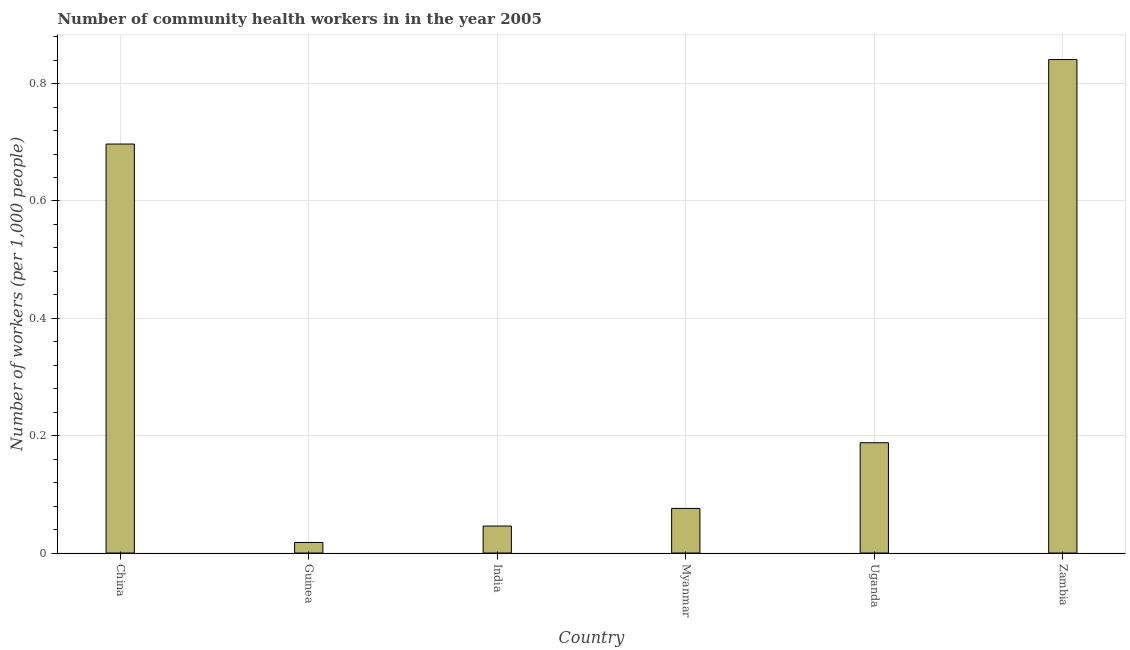Does the graph contain grids?
Your answer should be very brief. Yes. What is the title of the graph?
Give a very brief answer. Number of community health workers in in the year 2005. What is the label or title of the X-axis?
Offer a terse response. Country. What is the label or title of the Y-axis?
Your response must be concise. Number of workers (per 1,0 people). What is the number of community health workers in China?
Your answer should be compact. 0.7. Across all countries, what is the maximum number of community health workers?
Your answer should be compact. 0.84. Across all countries, what is the minimum number of community health workers?
Make the answer very short. 0.02. In which country was the number of community health workers maximum?
Offer a terse response. Zambia. In which country was the number of community health workers minimum?
Offer a terse response. Guinea. What is the sum of the number of community health workers?
Offer a very short reply. 1.87. What is the difference between the number of community health workers in China and Zambia?
Ensure brevity in your answer.  -0.14. What is the average number of community health workers per country?
Offer a terse response. 0.31. What is the median number of community health workers?
Your answer should be very brief. 0.13. In how many countries, is the number of community health workers greater than 0.44 ?
Give a very brief answer. 2. What is the ratio of the number of community health workers in Guinea to that in Myanmar?
Offer a very short reply. 0.24. Is the difference between the number of community health workers in Guinea and India greater than the difference between any two countries?
Provide a short and direct response. No. What is the difference between the highest and the second highest number of community health workers?
Make the answer very short. 0.14. Is the sum of the number of community health workers in India and Zambia greater than the maximum number of community health workers across all countries?
Give a very brief answer. Yes. What is the difference between the highest and the lowest number of community health workers?
Your answer should be compact. 0.82. What is the difference between two consecutive major ticks on the Y-axis?
Provide a succinct answer. 0.2. Are the values on the major ticks of Y-axis written in scientific E-notation?
Offer a very short reply. No. What is the Number of workers (per 1,000 people) in China?
Make the answer very short. 0.7. What is the Number of workers (per 1,000 people) of Guinea?
Offer a very short reply. 0.02. What is the Number of workers (per 1,000 people) of India?
Keep it short and to the point. 0.05. What is the Number of workers (per 1,000 people) of Myanmar?
Provide a succinct answer. 0.08. What is the Number of workers (per 1,000 people) in Uganda?
Offer a terse response. 0.19. What is the Number of workers (per 1,000 people) in Zambia?
Your answer should be very brief. 0.84. What is the difference between the Number of workers (per 1,000 people) in China and Guinea?
Keep it short and to the point. 0.68. What is the difference between the Number of workers (per 1,000 people) in China and India?
Provide a succinct answer. 0.65. What is the difference between the Number of workers (per 1,000 people) in China and Myanmar?
Provide a short and direct response. 0.62. What is the difference between the Number of workers (per 1,000 people) in China and Uganda?
Your answer should be compact. 0.51. What is the difference between the Number of workers (per 1,000 people) in China and Zambia?
Your answer should be very brief. -0.14. What is the difference between the Number of workers (per 1,000 people) in Guinea and India?
Provide a short and direct response. -0.03. What is the difference between the Number of workers (per 1,000 people) in Guinea and Myanmar?
Make the answer very short. -0.06. What is the difference between the Number of workers (per 1,000 people) in Guinea and Uganda?
Provide a short and direct response. -0.17. What is the difference between the Number of workers (per 1,000 people) in Guinea and Zambia?
Offer a very short reply. -0.82. What is the difference between the Number of workers (per 1,000 people) in India and Myanmar?
Keep it short and to the point. -0.03. What is the difference between the Number of workers (per 1,000 people) in India and Uganda?
Your response must be concise. -0.14. What is the difference between the Number of workers (per 1,000 people) in India and Zambia?
Your response must be concise. -0.8. What is the difference between the Number of workers (per 1,000 people) in Myanmar and Uganda?
Give a very brief answer. -0.11. What is the difference between the Number of workers (per 1,000 people) in Myanmar and Zambia?
Provide a short and direct response. -0.77. What is the difference between the Number of workers (per 1,000 people) in Uganda and Zambia?
Offer a very short reply. -0.65. What is the ratio of the Number of workers (per 1,000 people) in China to that in Guinea?
Provide a succinct answer. 38.72. What is the ratio of the Number of workers (per 1,000 people) in China to that in India?
Your answer should be very brief. 15.15. What is the ratio of the Number of workers (per 1,000 people) in China to that in Myanmar?
Offer a very short reply. 9.17. What is the ratio of the Number of workers (per 1,000 people) in China to that in Uganda?
Provide a succinct answer. 3.71. What is the ratio of the Number of workers (per 1,000 people) in China to that in Zambia?
Your answer should be very brief. 0.83. What is the ratio of the Number of workers (per 1,000 people) in Guinea to that in India?
Give a very brief answer. 0.39. What is the ratio of the Number of workers (per 1,000 people) in Guinea to that in Myanmar?
Make the answer very short. 0.24. What is the ratio of the Number of workers (per 1,000 people) in Guinea to that in Uganda?
Give a very brief answer. 0.1. What is the ratio of the Number of workers (per 1,000 people) in Guinea to that in Zambia?
Provide a succinct answer. 0.02. What is the ratio of the Number of workers (per 1,000 people) in India to that in Myanmar?
Ensure brevity in your answer.  0.6. What is the ratio of the Number of workers (per 1,000 people) in India to that in Uganda?
Make the answer very short. 0.24. What is the ratio of the Number of workers (per 1,000 people) in India to that in Zambia?
Provide a succinct answer. 0.06. What is the ratio of the Number of workers (per 1,000 people) in Myanmar to that in Uganda?
Your response must be concise. 0.4. What is the ratio of the Number of workers (per 1,000 people) in Myanmar to that in Zambia?
Your answer should be compact. 0.09. What is the ratio of the Number of workers (per 1,000 people) in Uganda to that in Zambia?
Give a very brief answer. 0.22. 